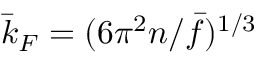<formula> <loc_0><loc_0><loc_500><loc_500>\bar { k } _ { F } = ( 6 \pi ^ { 2 } n / \bar { f } ) ^ { 1 / 3 }</formula> 